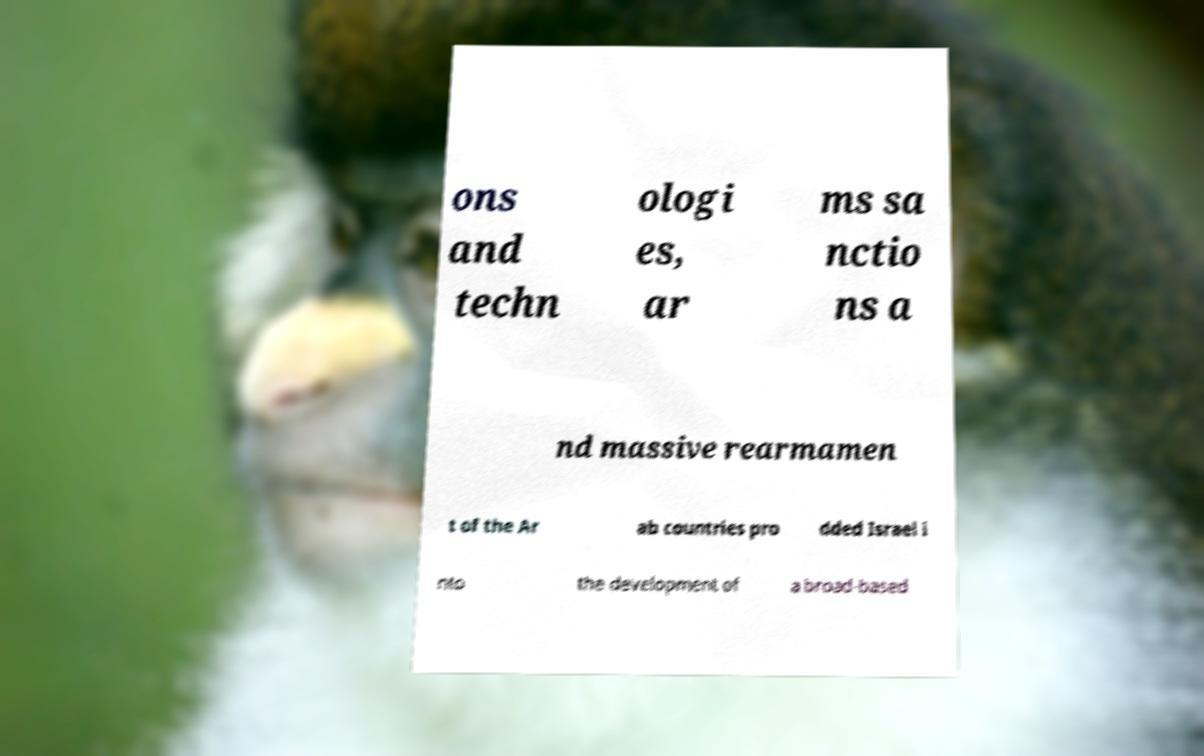I need the written content from this picture converted into text. Can you do that? ons and techn ologi es, ar ms sa nctio ns a nd massive rearmamen t of the Ar ab countries pro dded Israel i nto the development of a broad-based 